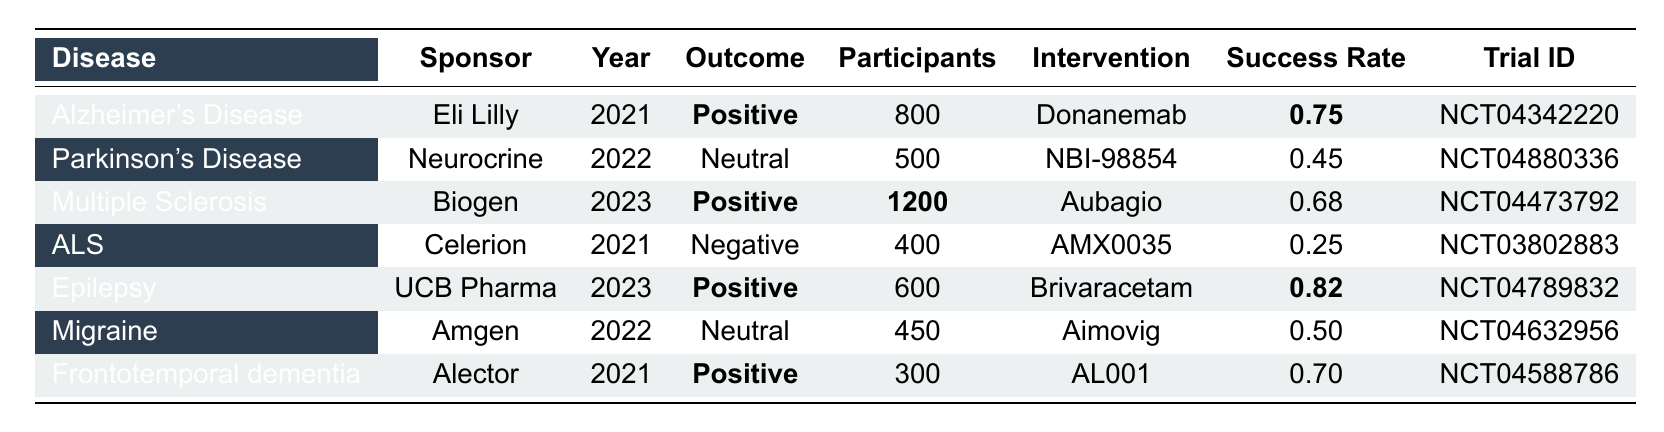What disease had the highest success rate among the clinical trials? The success rates are: Alzheimer's Disease (0.75), Parkinson's Disease (0.45), Multiple Sclerosis (0.68), ALS (0.25), Epilepsy (0.82), Migraine (0.50), and Frontotemporal dementia (0.70). The highest success rate is for Epilepsy at 0.82.
Answer: Epilepsy Which trial sponsored by Biogen had a positive outcome? The trial sponsored by Biogen is for Multiple Sclerosis, which has a positive outcome and a success rate of 0.68.
Answer: Multiple Sclerosis What is the total number of participants in trials with a positive outcome? The positive outcome trials include Alzheimer's Disease (800), Multiple Sclerosis (1200), Epilepsy (600), and Frontotemporal dementia (300). The total participants are 800 + 1200 + 600 + 300 = 2900.
Answer: 2900 Is the outcome of the trial for ALS positive? The outcome for ALS, which had AMX0035 as the intervention, is listed as Negative.
Answer: No Which disease had the smallest number of participants in a clinical trial? The trials and their participant numbers are: Alzheimer's Disease (800), Parkinson's Disease (500), Multiple Sclerosis (1200), ALS (400), Epilepsy (600), Migraine (450), and Frontotemporal dementia (300). The smallest is ALS with 400 participants.
Answer: ALS What percentage of trials reported positive outcomes? Among the trials, 4 out of 7 total trials reported positive outcomes. To find the percentage, divide 4 by 7 and multiply by 100, which gives approximately 57.14%.
Answer: Approximately 57.14% How many trials had a neutral outcome? The trials listed as neutral are for Parkinson's Disease and Migraine, totaling 2 trials.
Answer: 2 Are there more trials with a success rate above or below 0.5? The success rates above 0.5 are for Alzheimer's Disease (0.75), Multiple Sclerosis (0.68), Epilepsy (0.82), and Frontotemporal dementia (0.70), totaling 4 trials. Those below 0.5 are Parkinson's Disease (0.45), ALS (0.25), and Migraine (0.50), totaling 3 trials. There are more above 0.5.
Answer: More above 0.5 Which intervention had the least number of participants and still produced a positive outcome? The only intervention with a positive outcome and less than 600 participants is Frontotemporal dementia (300 participants) with the intervention AL001.
Answer: AL001 